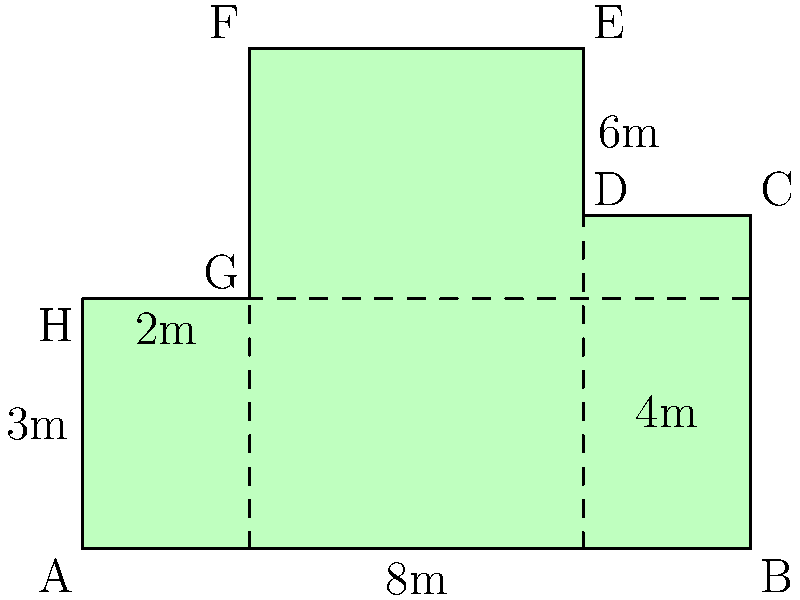In your latest crime thriller, a murder takes place in an irregularly shaped room of a luxurious mansion. The forensics team needs to calculate the exact area of the room to determine the amount of luminol required for blood trace detection. Given the dimensions shown in the floor plan (in meters), what is the total area of the room in square meters? To solve this problem, we can decompose the irregular shape into simpler geometric shapes:

1. Divide the room into three rectangles:
   - Rectangle 1: ABCH (bottom)
   - Rectangle 2: CDEG (right)
   - Rectangle 3: FGH (top left)

2. Calculate the area of each rectangle:
   - Area of Rectangle 1: $8 \times 3 = 24$ m²
   - Area of Rectangle 2: $2 \times 6 = 12$ m²
   - Area of Rectangle 3: $2 \times 3 = 6$ m²

3. Sum up the areas of all rectangles:
   $\text{Total Area} = 24 + 12 + 6 = 42$ m²

Therefore, the total area of the irregularly shaped room is 42 square meters.
Answer: 42 m² 